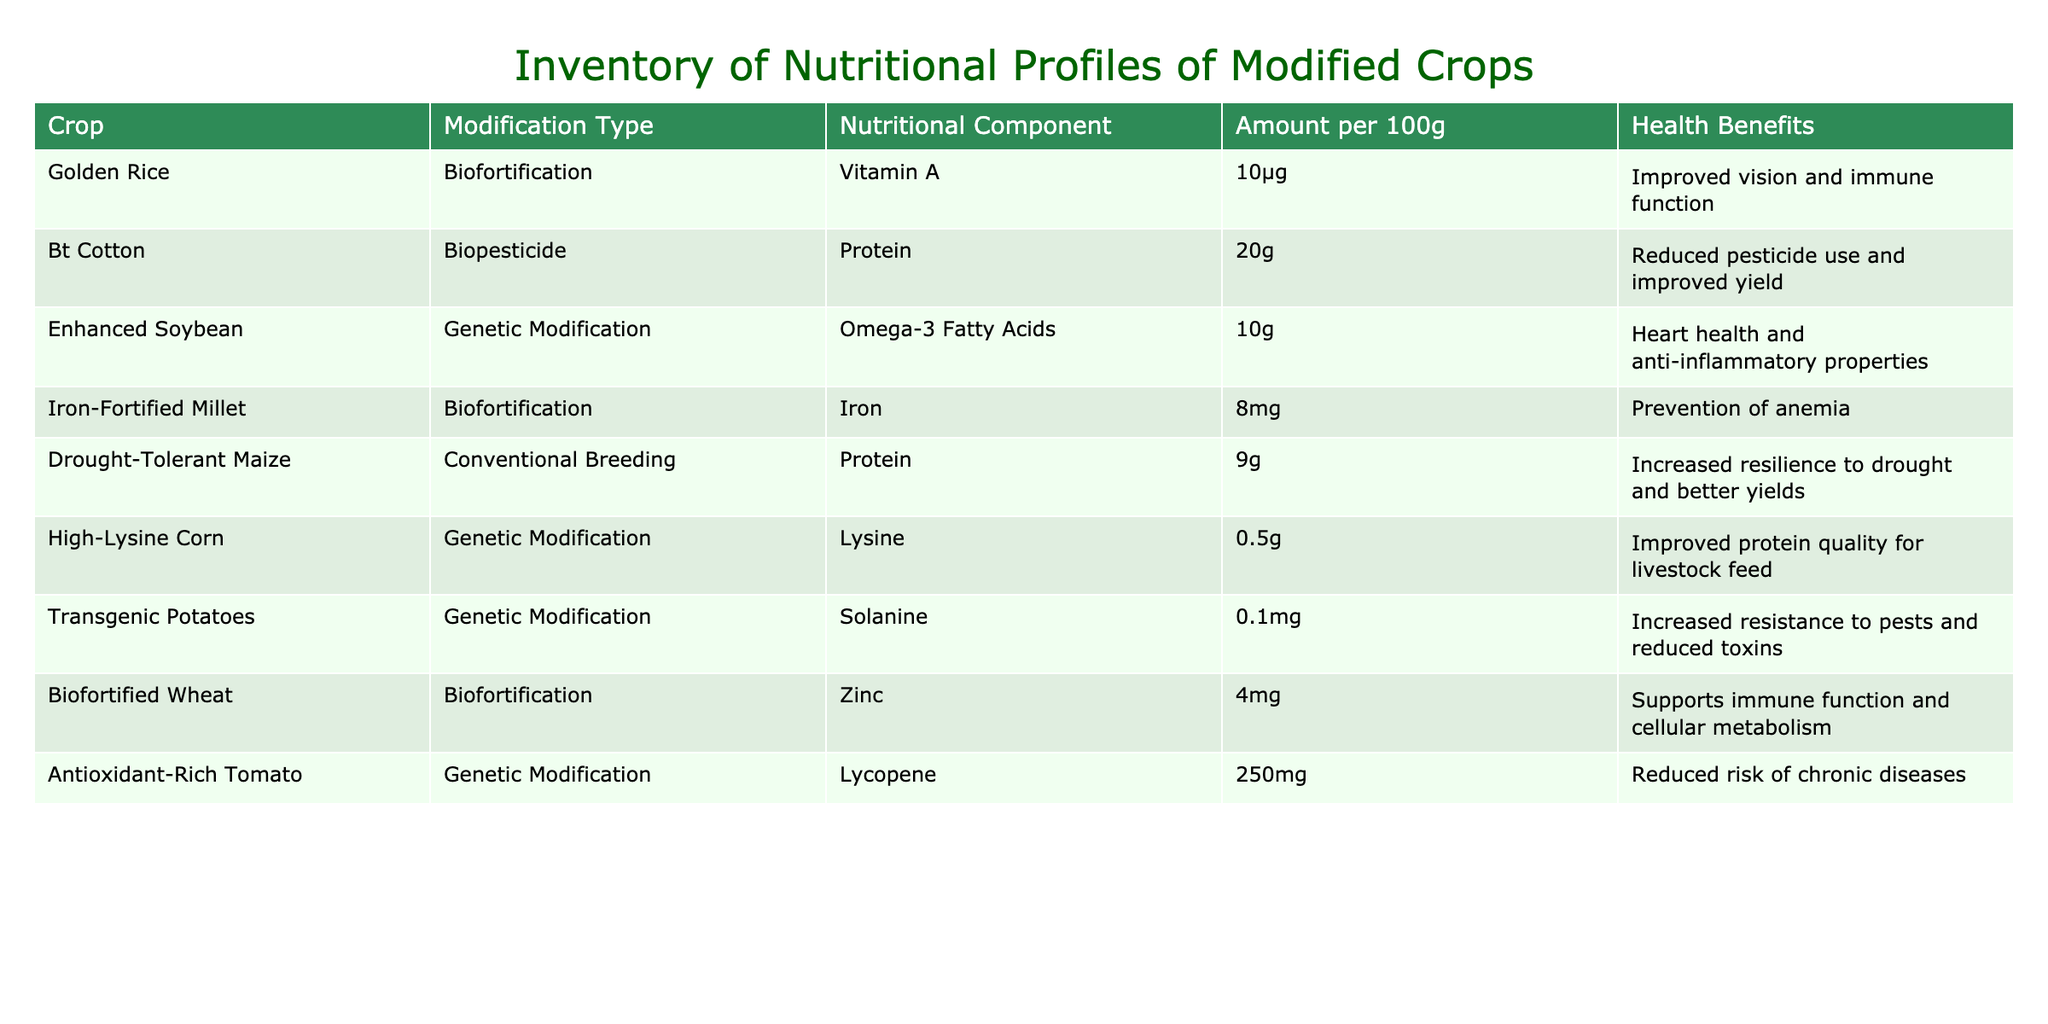What crop has the highest amount of Omega-3 Fatty Acids? Looking at the table, the Enhanced Soybean is listed with an amount of 10g of Omega-3 Fatty Acids, which is notably higher than any other crop.
Answer: Enhanced Soybean Does Golden Rice provide any health benefits? The table indicates that Golden Rice has a health benefit of improved vision and immune function due to its Vitamin A content.
Answer: Yes What is the average amount of protein in the crops listed? The crops with protein content are Bt Cotton (20g), Drought-Tolerant Maize (9g), and High-Lysine Corn (0.5g). To find the average, we sum these amounts: 20 + 9 + 0.5 = 29.5 and divide by 3 (the number of crops), which gives approximately 9.83g.
Answer: 9.83g Is there any crop in the inventory that is biofortified with Iron? The Iron-Fortified Millet is specifically mentioned to have Iron content (8 mg) and is categorized under biofortification. Thus, there is a crop biofortified with Iron.
Answer: Yes Which modified crop has the least amount of Solanine? The Transgenic Potatoes have an amount of 0.1mg of Solanine, which is the lowest compared to any other crop that might have Solanine listed.
Answer: Transgenic Potatoes What nutritional component does High-Lysine Corn provide? According to the table, High-Lysine Corn provides Lysine, with an amount of 0.5g per 100g.
Answer: Lysine How many crops have a health benefit associated with support for immune function? Two crops in the table mention a health benefit related to immune function: Golden Rice (improved vision and immune function) and Biofortified Wheat (supports immune function and cellular metabolism). Therefore, the answer is 2.
Answer: 2 Which crop shows a reduction in pesticide use? The Bt Cotton is highlighted for its protein content and mentions a health benefit of reduced pesticide use and improved yield.
Answer: Bt Cotton Are any of the crops modified through conventional breeding? The Drought-Tolerant Maize is specifically listed under conventional breeding, indicating that it is indeed one of the crops modified through this method.
Answer: Yes 